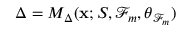Convert formula to latex. <formula><loc_0><loc_0><loc_500><loc_500>\Delta = M _ { \Delta } ( x ; S , \mathcal { F } _ { m } , \theta _ { \mathcal { F } _ { m } } )</formula> 